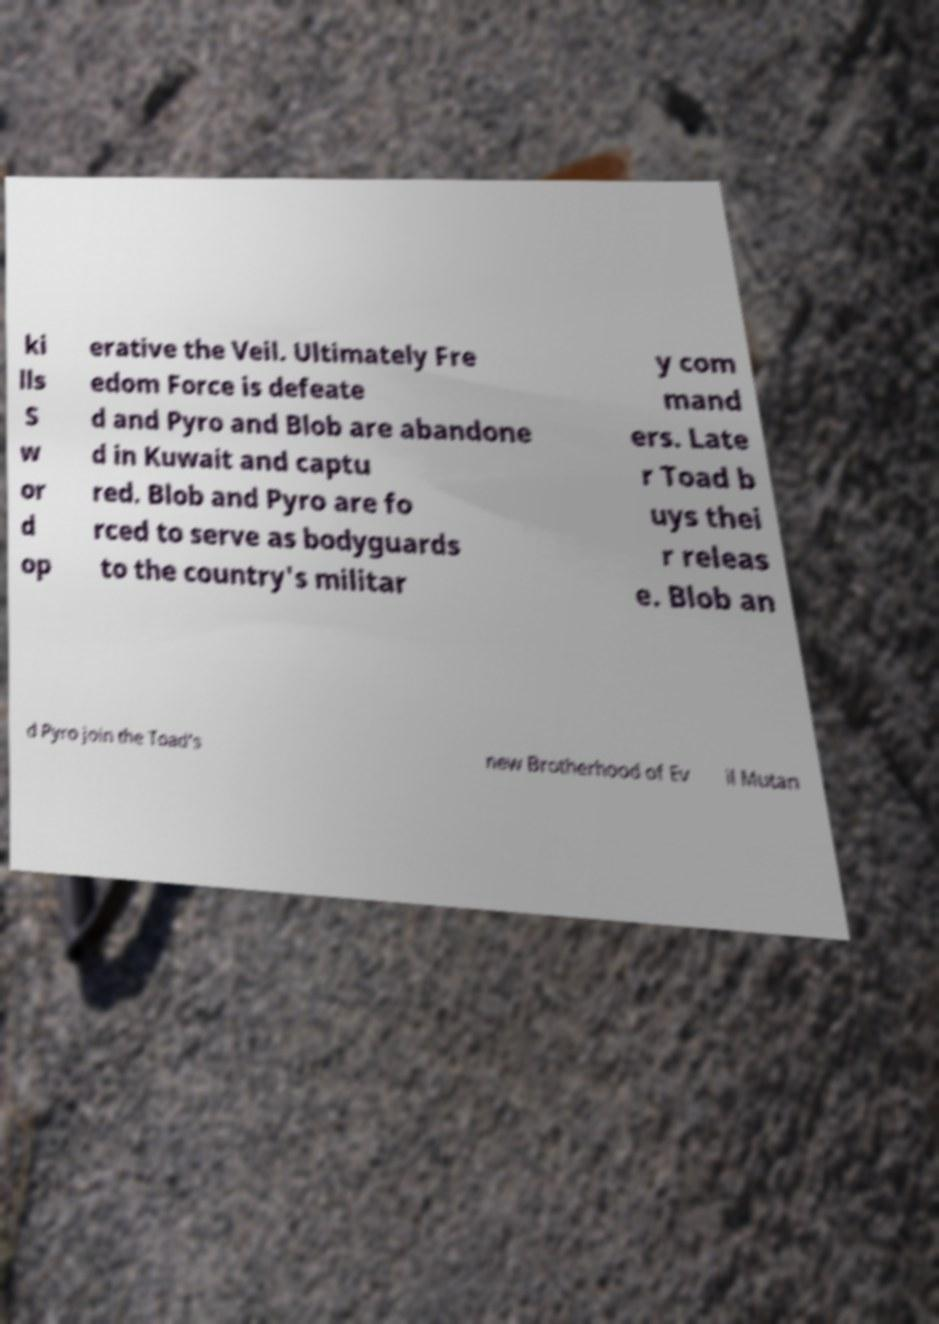Could you assist in decoding the text presented in this image and type it out clearly? ki lls S w or d op erative the Veil. Ultimately Fre edom Force is defeate d and Pyro and Blob are abandone d in Kuwait and captu red. Blob and Pyro are fo rced to serve as bodyguards to the country's militar y com mand ers. Late r Toad b uys thei r releas e. Blob an d Pyro join the Toad's new Brotherhood of Ev il Mutan 